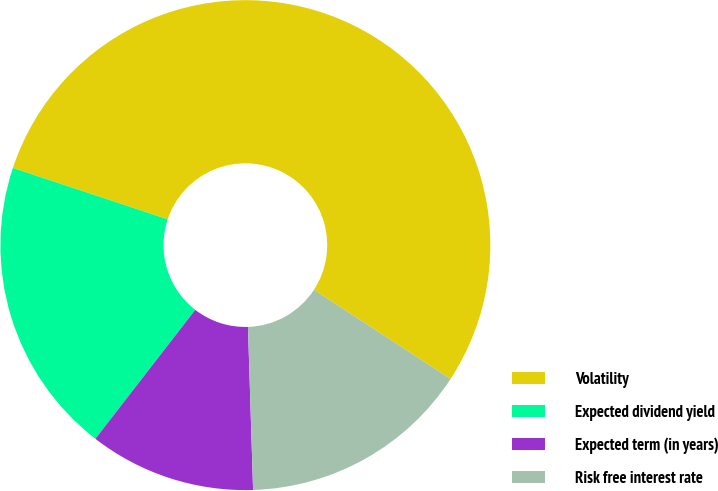<chart> <loc_0><loc_0><loc_500><loc_500><pie_chart><fcel>Volatility<fcel>Expected dividend yield<fcel>Expected term (in years)<fcel>Risk free interest rate<nl><fcel>54.09%<fcel>19.61%<fcel>10.99%<fcel>15.3%<nl></chart> 